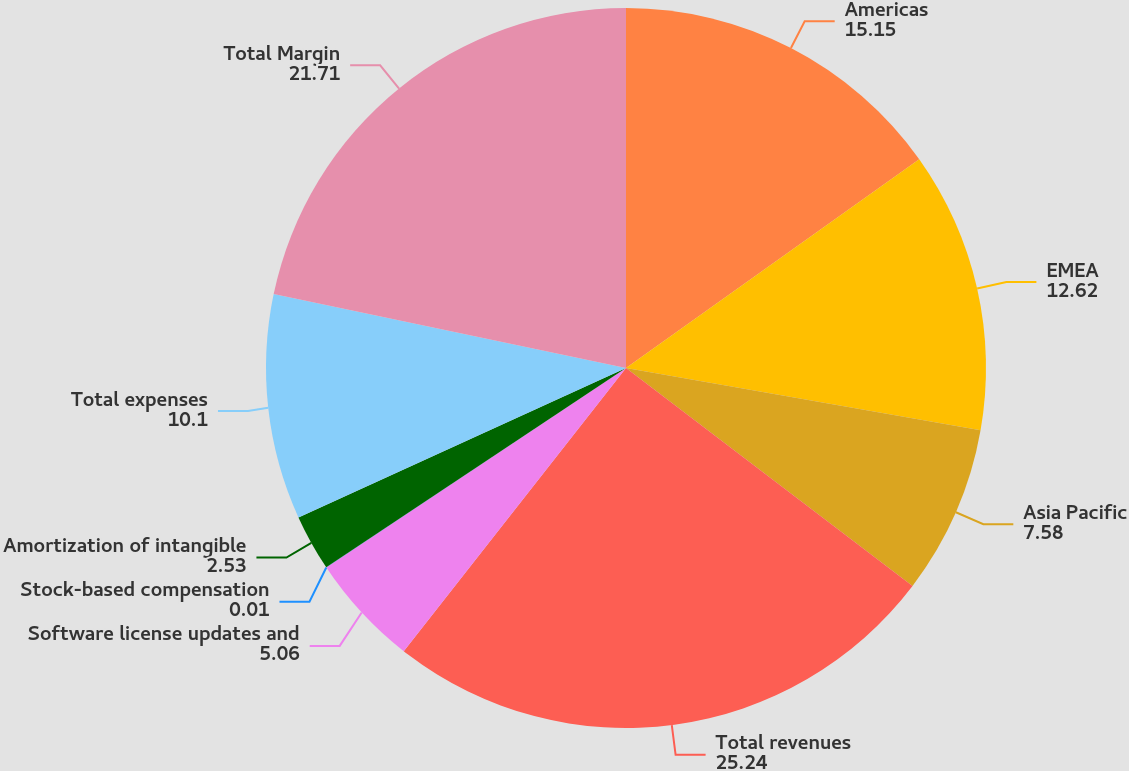<chart> <loc_0><loc_0><loc_500><loc_500><pie_chart><fcel>Americas<fcel>EMEA<fcel>Asia Pacific<fcel>Total revenues<fcel>Software license updates and<fcel>Stock-based compensation<fcel>Amortization of intangible<fcel>Total expenses<fcel>Total Margin<nl><fcel>15.15%<fcel>12.62%<fcel>7.58%<fcel>25.24%<fcel>5.06%<fcel>0.01%<fcel>2.53%<fcel>10.1%<fcel>21.71%<nl></chart> 